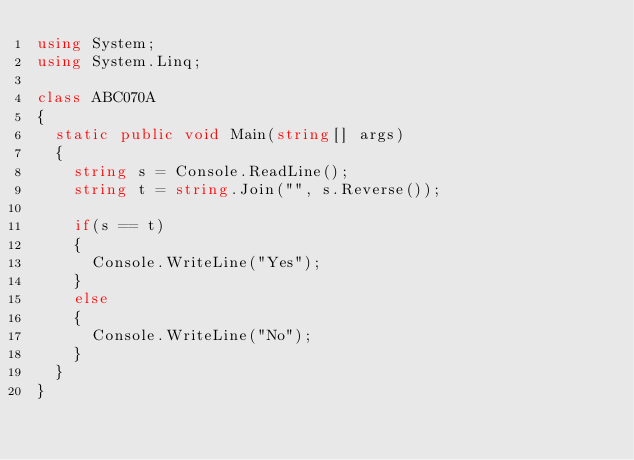Convert code to text. <code><loc_0><loc_0><loc_500><loc_500><_C#_>using System;
using System.Linq;

class ABC070A
{
	static public void Main(string[] args)
	{
		string s = Console.ReadLine();
		string t = string.Join("", s.Reverse());

		if(s == t)
		{
			Console.WriteLine("Yes");
		}
		else
		{
			Console.WriteLine("No");
		}
	}
}
</code> 